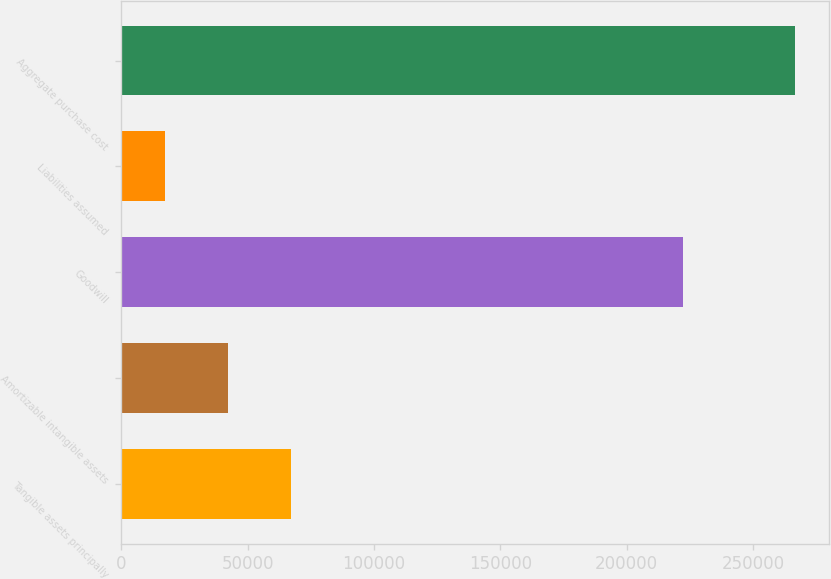Convert chart to OTSL. <chart><loc_0><loc_0><loc_500><loc_500><bar_chart><fcel>Tangible assets principally<fcel>Amortizable intangible assets<fcel>Goodwill<fcel>Liabilities assumed<fcel>Aggregate purchase cost<nl><fcel>67223.6<fcel>42289.8<fcel>222424<fcel>17356<fcel>266694<nl></chart> 